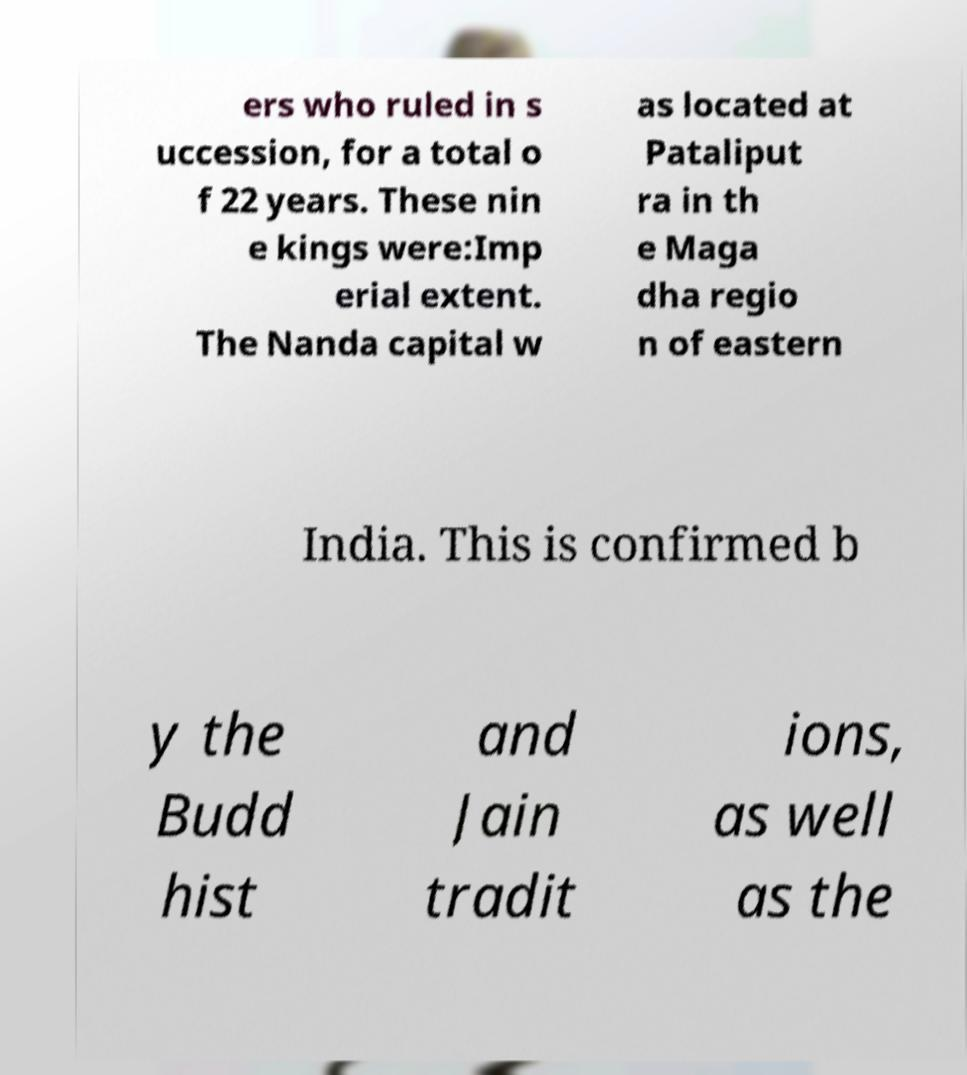What messages or text are displayed in this image? I need them in a readable, typed format. ers who ruled in s uccession, for a total o f 22 years. These nin e kings were:Imp erial extent. The Nanda capital w as located at Pataliput ra in th e Maga dha regio n of eastern India. This is confirmed b y the Budd hist and Jain tradit ions, as well as the 